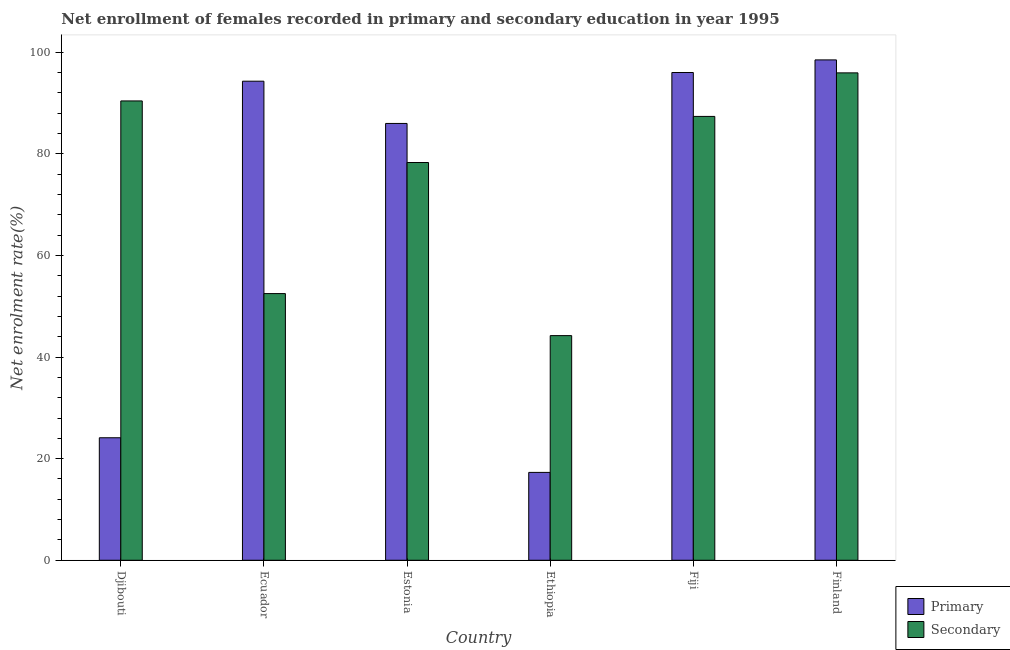How many different coloured bars are there?
Keep it short and to the point. 2. How many bars are there on the 5th tick from the left?
Provide a short and direct response. 2. What is the label of the 6th group of bars from the left?
Provide a succinct answer. Finland. What is the enrollment rate in primary education in Ecuador?
Offer a very short reply. 94.3. Across all countries, what is the maximum enrollment rate in primary education?
Make the answer very short. 98.5. Across all countries, what is the minimum enrollment rate in primary education?
Your answer should be very brief. 17.3. In which country was the enrollment rate in primary education minimum?
Your answer should be very brief. Ethiopia. What is the total enrollment rate in secondary education in the graph?
Make the answer very short. 448.74. What is the difference between the enrollment rate in secondary education in Ethiopia and that in Finland?
Your response must be concise. -51.72. What is the difference between the enrollment rate in primary education in Ecuador and the enrollment rate in secondary education in Finland?
Offer a terse response. -1.64. What is the average enrollment rate in primary education per country?
Provide a short and direct response. 69.37. What is the difference between the enrollment rate in secondary education and enrollment rate in primary education in Ethiopia?
Keep it short and to the point. 26.93. In how many countries, is the enrollment rate in secondary education greater than 52 %?
Give a very brief answer. 5. What is the ratio of the enrollment rate in primary education in Estonia to that in Finland?
Keep it short and to the point. 0.87. Is the enrollment rate in primary education in Djibouti less than that in Fiji?
Make the answer very short. Yes. Is the difference between the enrollment rate in secondary education in Djibouti and Ecuador greater than the difference between the enrollment rate in primary education in Djibouti and Ecuador?
Ensure brevity in your answer.  Yes. What is the difference between the highest and the second highest enrollment rate in secondary education?
Give a very brief answer. 5.52. What is the difference between the highest and the lowest enrollment rate in secondary education?
Ensure brevity in your answer.  51.72. What does the 1st bar from the left in Estonia represents?
Your answer should be compact. Primary. What does the 1st bar from the right in Ethiopia represents?
Your answer should be very brief. Secondary. Are all the bars in the graph horizontal?
Offer a very short reply. No. How many countries are there in the graph?
Ensure brevity in your answer.  6. What is the difference between two consecutive major ticks on the Y-axis?
Your answer should be very brief. 20. Where does the legend appear in the graph?
Give a very brief answer. Bottom right. How many legend labels are there?
Make the answer very short. 2. What is the title of the graph?
Ensure brevity in your answer.  Net enrollment of females recorded in primary and secondary education in year 1995. Does "% of GNI" appear as one of the legend labels in the graph?
Your answer should be very brief. No. What is the label or title of the Y-axis?
Your response must be concise. Net enrolment rate(%). What is the Net enrolment rate(%) of Primary in Djibouti?
Keep it short and to the point. 24.11. What is the Net enrolment rate(%) in Secondary in Djibouti?
Provide a short and direct response. 90.42. What is the Net enrolment rate(%) in Primary in Ecuador?
Your answer should be very brief. 94.3. What is the Net enrolment rate(%) of Secondary in Ecuador?
Provide a short and direct response. 52.5. What is the Net enrolment rate(%) in Primary in Estonia?
Provide a succinct answer. 85.98. What is the Net enrolment rate(%) in Secondary in Estonia?
Your response must be concise. 78.3. What is the Net enrolment rate(%) of Primary in Ethiopia?
Keep it short and to the point. 17.3. What is the Net enrolment rate(%) in Secondary in Ethiopia?
Offer a terse response. 44.22. What is the Net enrolment rate(%) of Primary in Fiji?
Provide a succinct answer. 96.01. What is the Net enrolment rate(%) in Secondary in Fiji?
Offer a very short reply. 87.37. What is the Net enrolment rate(%) of Primary in Finland?
Your answer should be compact. 98.5. What is the Net enrolment rate(%) in Secondary in Finland?
Make the answer very short. 95.94. Across all countries, what is the maximum Net enrolment rate(%) of Primary?
Offer a very short reply. 98.5. Across all countries, what is the maximum Net enrolment rate(%) in Secondary?
Your answer should be compact. 95.94. Across all countries, what is the minimum Net enrolment rate(%) of Primary?
Offer a terse response. 17.3. Across all countries, what is the minimum Net enrolment rate(%) of Secondary?
Offer a terse response. 44.22. What is the total Net enrolment rate(%) in Primary in the graph?
Give a very brief answer. 416.21. What is the total Net enrolment rate(%) of Secondary in the graph?
Give a very brief answer. 448.74. What is the difference between the Net enrolment rate(%) in Primary in Djibouti and that in Ecuador?
Provide a short and direct response. -70.19. What is the difference between the Net enrolment rate(%) of Secondary in Djibouti and that in Ecuador?
Your answer should be very brief. 37.92. What is the difference between the Net enrolment rate(%) in Primary in Djibouti and that in Estonia?
Offer a terse response. -61.87. What is the difference between the Net enrolment rate(%) of Secondary in Djibouti and that in Estonia?
Provide a short and direct response. 12.12. What is the difference between the Net enrolment rate(%) in Primary in Djibouti and that in Ethiopia?
Ensure brevity in your answer.  6.82. What is the difference between the Net enrolment rate(%) of Secondary in Djibouti and that in Ethiopia?
Provide a succinct answer. 46.2. What is the difference between the Net enrolment rate(%) of Primary in Djibouti and that in Fiji?
Offer a terse response. -71.9. What is the difference between the Net enrolment rate(%) of Secondary in Djibouti and that in Fiji?
Ensure brevity in your answer.  3.05. What is the difference between the Net enrolment rate(%) in Primary in Djibouti and that in Finland?
Give a very brief answer. -74.38. What is the difference between the Net enrolment rate(%) of Secondary in Djibouti and that in Finland?
Keep it short and to the point. -5.52. What is the difference between the Net enrolment rate(%) in Primary in Ecuador and that in Estonia?
Ensure brevity in your answer.  8.32. What is the difference between the Net enrolment rate(%) in Secondary in Ecuador and that in Estonia?
Give a very brief answer. -25.8. What is the difference between the Net enrolment rate(%) in Primary in Ecuador and that in Ethiopia?
Ensure brevity in your answer.  77.01. What is the difference between the Net enrolment rate(%) of Secondary in Ecuador and that in Ethiopia?
Offer a terse response. 8.27. What is the difference between the Net enrolment rate(%) in Primary in Ecuador and that in Fiji?
Offer a very short reply. -1.71. What is the difference between the Net enrolment rate(%) in Secondary in Ecuador and that in Fiji?
Your answer should be very brief. -34.88. What is the difference between the Net enrolment rate(%) of Primary in Ecuador and that in Finland?
Provide a succinct answer. -4.19. What is the difference between the Net enrolment rate(%) in Secondary in Ecuador and that in Finland?
Provide a short and direct response. -43.45. What is the difference between the Net enrolment rate(%) of Primary in Estonia and that in Ethiopia?
Your response must be concise. 68.69. What is the difference between the Net enrolment rate(%) in Secondary in Estonia and that in Ethiopia?
Keep it short and to the point. 34.08. What is the difference between the Net enrolment rate(%) of Primary in Estonia and that in Fiji?
Provide a short and direct response. -10.03. What is the difference between the Net enrolment rate(%) in Secondary in Estonia and that in Fiji?
Provide a succinct answer. -9.07. What is the difference between the Net enrolment rate(%) of Primary in Estonia and that in Finland?
Ensure brevity in your answer.  -12.51. What is the difference between the Net enrolment rate(%) of Secondary in Estonia and that in Finland?
Keep it short and to the point. -17.64. What is the difference between the Net enrolment rate(%) in Primary in Ethiopia and that in Fiji?
Offer a very short reply. -78.72. What is the difference between the Net enrolment rate(%) of Secondary in Ethiopia and that in Fiji?
Provide a succinct answer. -43.15. What is the difference between the Net enrolment rate(%) of Primary in Ethiopia and that in Finland?
Keep it short and to the point. -81.2. What is the difference between the Net enrolment rate(%) in Secondary in Ethiopia and that in Finland?
Provide a short and direct response. -51.72. What is the difference between the Net enrolment rate(%) of Primary in Fiji and that in Finland?
Ensure brevity in your answer.  -2.48. What is the difference between the Net enrolment rate(%) of Secondary in Fiji and that in Finland?
Your answer should be very brief. -8.57. What is the difference between the Net enrolment rate(%) of Primary in Djibouti and the Net enrolment rate(%) of Secondary in Ecuador?
Keep it short and to the point. -28.38. What is the difference between the Net enrolment rate(%) of Primary in Djibouti and the Net enrolment rate(%) of Secondary in Estonia?
Your answer should be compact. -54.18. What is the difference between the Net enrolment rate(%) of Primary in Djibouti and the Net enrolment rate(%) of Secondary in Ethiopia?
Your response must be concise. -20.11. What is the difference between the Net enrolment rate(%) of Primary in Djibouti and the Net enrolment rate(%) of Secondary in Fiji?
Provide a short and direct response. -63.26. What is the difference between the Net enrolment rate(%) in Primary in Djibouti and the Net enrolment rate(%) in Secondary in Finland?
Your answer should be very brief. -71.83. What is the difference between the Net enrolment rate(%) in Primary in Ecuador and the Net enrolment rate(%) in Secondary in Estonia?
Ensure brevity in your answer.  16.01. What is the difference between the Net enrolment rate(%) of Primary in Ecuador and the Net enrolment rate(%) of Secondary in Ethiopia?
Make the answer very short. 50.08. What is the difference between the Net enrolment rate(%) of Primary in Ecuador and the Net enrolment rate(%) of Secondary in Fiji?
Ensure brevity in your answer.  6.93. What is the difference between the Net enrolment rate(%) of Primary in Ecuador and the Net enrolment rate(%) of Secondary in Finland?
Your response must be concise. -1.64. What is the difference between the Net enrolment rate(%) of Primary in Estonia and the Net enrolment rate(%) of Secondary in Ethiopia?
Ensure brevity in your answer.  41.76. What is the difference between the Net enrolment rate(%) of Primary in Estonia and the Net enrolment rate(%) of Secondary in Fiji?
Your response must be concise. -1.39. What is the difference between the Net enrolment rate(%) in Primary in Estonia and the Net enrolment rate(%) in Secondary in Finland?
Give a very brief answer. -9.96. What is the difference between the Net enrolment rate(%) in Primary in Ethiopia and the Net enrolment rate(%) in Secondary in Fiji?
Make the answer very short. -70.07. What is the difference between the Net enrolment rate(%) of Primary in Ethiopia and the Net enrolment rate(%) of Secondary in Finland?
Your response must be concise. -78.65. What is the difference between the Net enrolment rate(%) in Primary in Fiji and the Net enrolment rate(%) in Secondary in Finland?
Provide a short and direct response. 0.07. What is the average Net enrolment rate(%) of Primary per country?
Offer a very short reply. 69.37. What is the average Net enrolment rate(%) in Secondary per country?
Give a very brief answer. 74.79. What is the difference between the Net enrolment rate(%) in Primary and Net enrolment rate(%) in Secondary in Djibouti?
Give a very brief answer. -66.3. What is the difference between the Net enrolment rate(%) of Primary and Net enrolment rate(%) of Secondary in Ecuador?
Your answer should be compact. 41.81. What is the difference between the Net enrolment rate(%) of Primary and Net enrolment rate(%) of Secondary in Estonia?
Provide a short and direct response. 7.69. What is the difference between the Net enrolment rate(%) of Primary and Net enrolment rate(%) of Secondary in Ethiopia?
Your answer should be very brief. -26.93. What is the difference between the Net enrolment rate(%) in Primary and Net enrolment rate(%) in Secondary in Fiji?
Ensure brevity in your answer.  8.64. What is the difference between the Net enrolment rate(%) in Primary and Net enrolment rate(%) in Secondary in Finland?
Provide a short and direct response. 2.55. What is the ratio of the Net enrolment rate(%) in Primary in Djibouti to that in Ecuador?
Your answer should be very brief. 0.26. What is the ratio of the Net enrolment rate(%) in Secondary in Djibouti to that in Ecuador?
Provide a short and direct response. 1.72. What is the ratio of the Net enrolment rate(%) of Primary in Djibouti to that in Estonia?
Provide a short and direct response. 0.28. What is the ratio of the Net enrolment rate(%) in Secondary in Djibouti to that in Estonia?
Your answer should be very brief. 1.15. What is the ratio of the Net enrolment rate(%) of Primary in Djibouti to that in Ethiopia?
Your answer should be very brief. 1.39. What is the ratio of the Net enrolment rate(%) in Secondary in Djibouti to that in Ethiopia?
Provide a short and direct response. 2.04. What is the ratio of the Net enrolment rate(%) in Primary in Djibouti to that in Fiji?
Keep it short and to the point. 0.25. What is the ratio of the Net enrolment rate(%) in Secondary in Djibouti to that in Fiji?
Your answer should be compact. 1.03. What is the ratio of the Net enrolment rate(%) of Primary in Djibouti to that in Finland?
Make the answer very short. 0.24. What is the ratio of the Net enrolment rate(%) of Secondary in Djibouti to that in Finland?
Your response must be concise. 0.94. What is the ratio of the Net enrolment rate(%) of Primary in Ecuador to that in Estonia?
Offer a terse response. 1.1. What is the ratio of the Net enrolment rate(%) of Secondary in Ecuador to that in Estonia?
Your answer should be compact. 0.67. What is the ratio of the Net enrolment rate(%) in Primary in Ecuador to that in Ethiopia?
Your response must be concise. 5.45. What is the ratio of the Net enrolment rate(%) in Secondary in Ecuador to that in Ethiopia?
Provide a succinct answer. 1.19. What is the ratio of the Net enrolment rate(%) in Primary in Ecuador to that in Fiji?
Your answer should be compact. 0.98. What is the ratio of the Net enrolment rate(%) of Secondary in Ecuador to that in Fiji?
Offer a terse response. 0.6. What is the ratio of the Net enrolment rate(%) in Primary in Ecuador to that in Finland?
Provide a short and direct response. 0.96. What is the ratio of the Net enrolment rate(%) of Secondary in Ecuador to that in Finland?
Your response must be concise. 0.55. What is the ratio of the Net enrolment rate(%) in Primary in Estonia to that in Ethiopia?
Provide a succinct answer. 4.97. What is the ratio of the Net enrolment rate(%) of Secondary in Estonia to that in Ethiopia?
Your answer should be very brief. 1.77. What is the ratio of the Net enrolment rate(%) of Primary in Estonia to that in Fiji?
Ensure brevity in your answer.  0.9. What is the ratio of the Net enrolment rate(%) of Secondary in Estonia to that in Fiji?
Offer a terse response. 0.9. What is the ratio of the Net enrolment rate(%) in Primary in Estonia to that in Finland?
Your answer should be very brief. 0.87. What is the ratio of the Net enrolment rate(%) in Secondary in Estonia to that in Finland?
Provide a short and direct response. 0.82. What is the ratio of the Net enrolment rate(%) in Primary in Ethiopia to that in Fiji?
Offer a very short reply. 0.18. What is the ratio of the Net enrolment rate(%) in Secondary in Ethiopia to that in Fiji?
Your answer should be very brief. 0.51. What is the ratio of the Net enrolment rate(%) of Primary in Ethiopia to that in Finland?
Provide a short and direct response. 0.18. What is the ratio of the Net enrolment rate(%) in Secondary in Ethiopia to that in Finland?
Provide a succinct answer. 0.46. What is the ratio of the Net enrolment rate(%) of Primary in Fiji to that in Finland?
Your response must be concise. 0.97. What is the ratio of the Net enrolment rate(%) in Secondary in Fiji to that in Finland?
Provide a short and direct response. 0.91. What is the difference between the highest and the second highest Net enrolment rate(%) of Primary?
Offer a terse response. 2.48. What is the difference between the highest and the second highest Net enrolment rate(%) in Secondary?
Offer a very short reply. 5.52. What is the difference between the highest and the lowest Net enrolment rate(%) of Primary?
Give a very brief answer. 81.2. What is the difference between the highest and the lowest Net enrolment rate(%) of Secondary?
Provide a succinct answer. 51.72. 